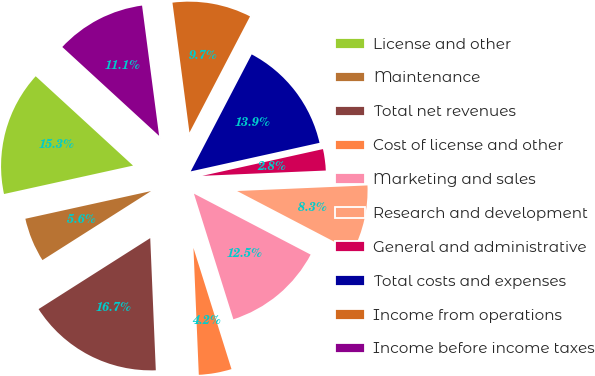Convert chart. <chart><loc_0><loc_0><loc_500><loc_500><pie_chart><fcel>License and other<fcel>Maintenance<fcel>Total net revenues<fcel>Cost of license and other<fcel>Marketing and sales<fcel>Research and development<fcel>General and administrative<fcel>Total costs and expenses<fcel>Income from operations<fcel>Income before income taxes<nl><fcel>15.27%<fcel>5.56%<fcel>16.66%<fcel>4.17%<fcel>12.5%<fcel>8.34%<fcel>2.79%<fcel>13.88%<fcel>9.72%<fcel>11.11%<nl></chart> 